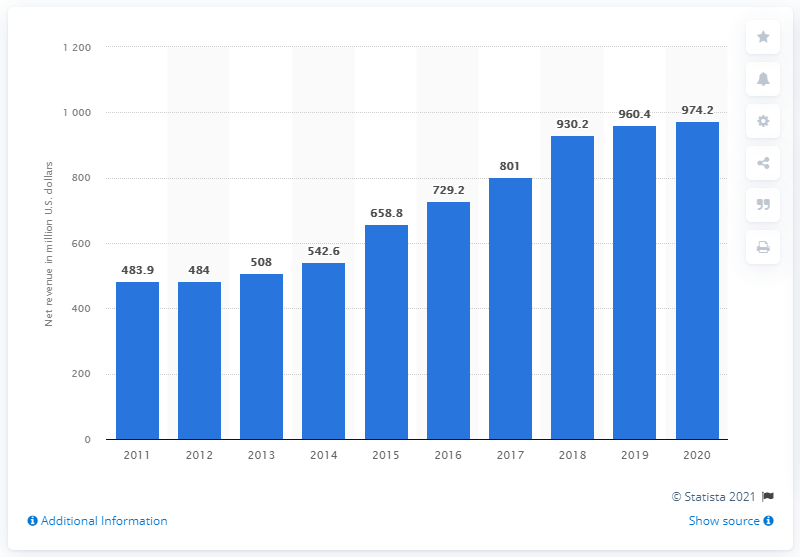Give some essential details in this illustration. World Wrestling Entertainment's global revenue in 2020 was 974.2 million dollars. In the previous year, the global revenue of World Wrestling Entertainment was approximately 960.4 million dollars. 